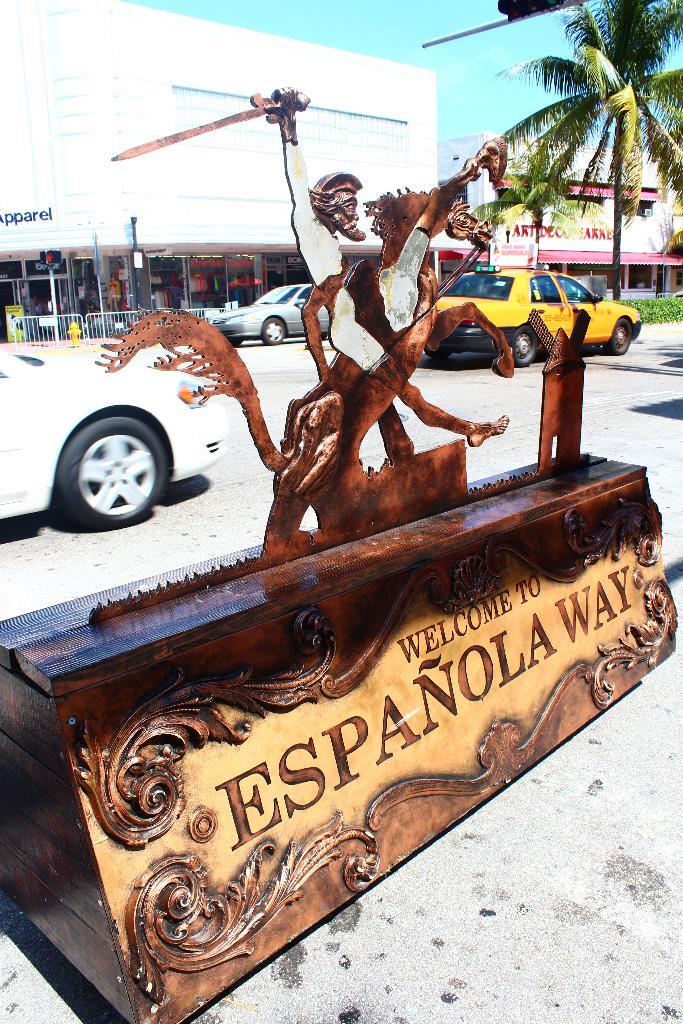Where is this photo taken?
Your answer should be very brief. Espanola way. What does the store in the background sell?
Your response must be concise. Apparel. 